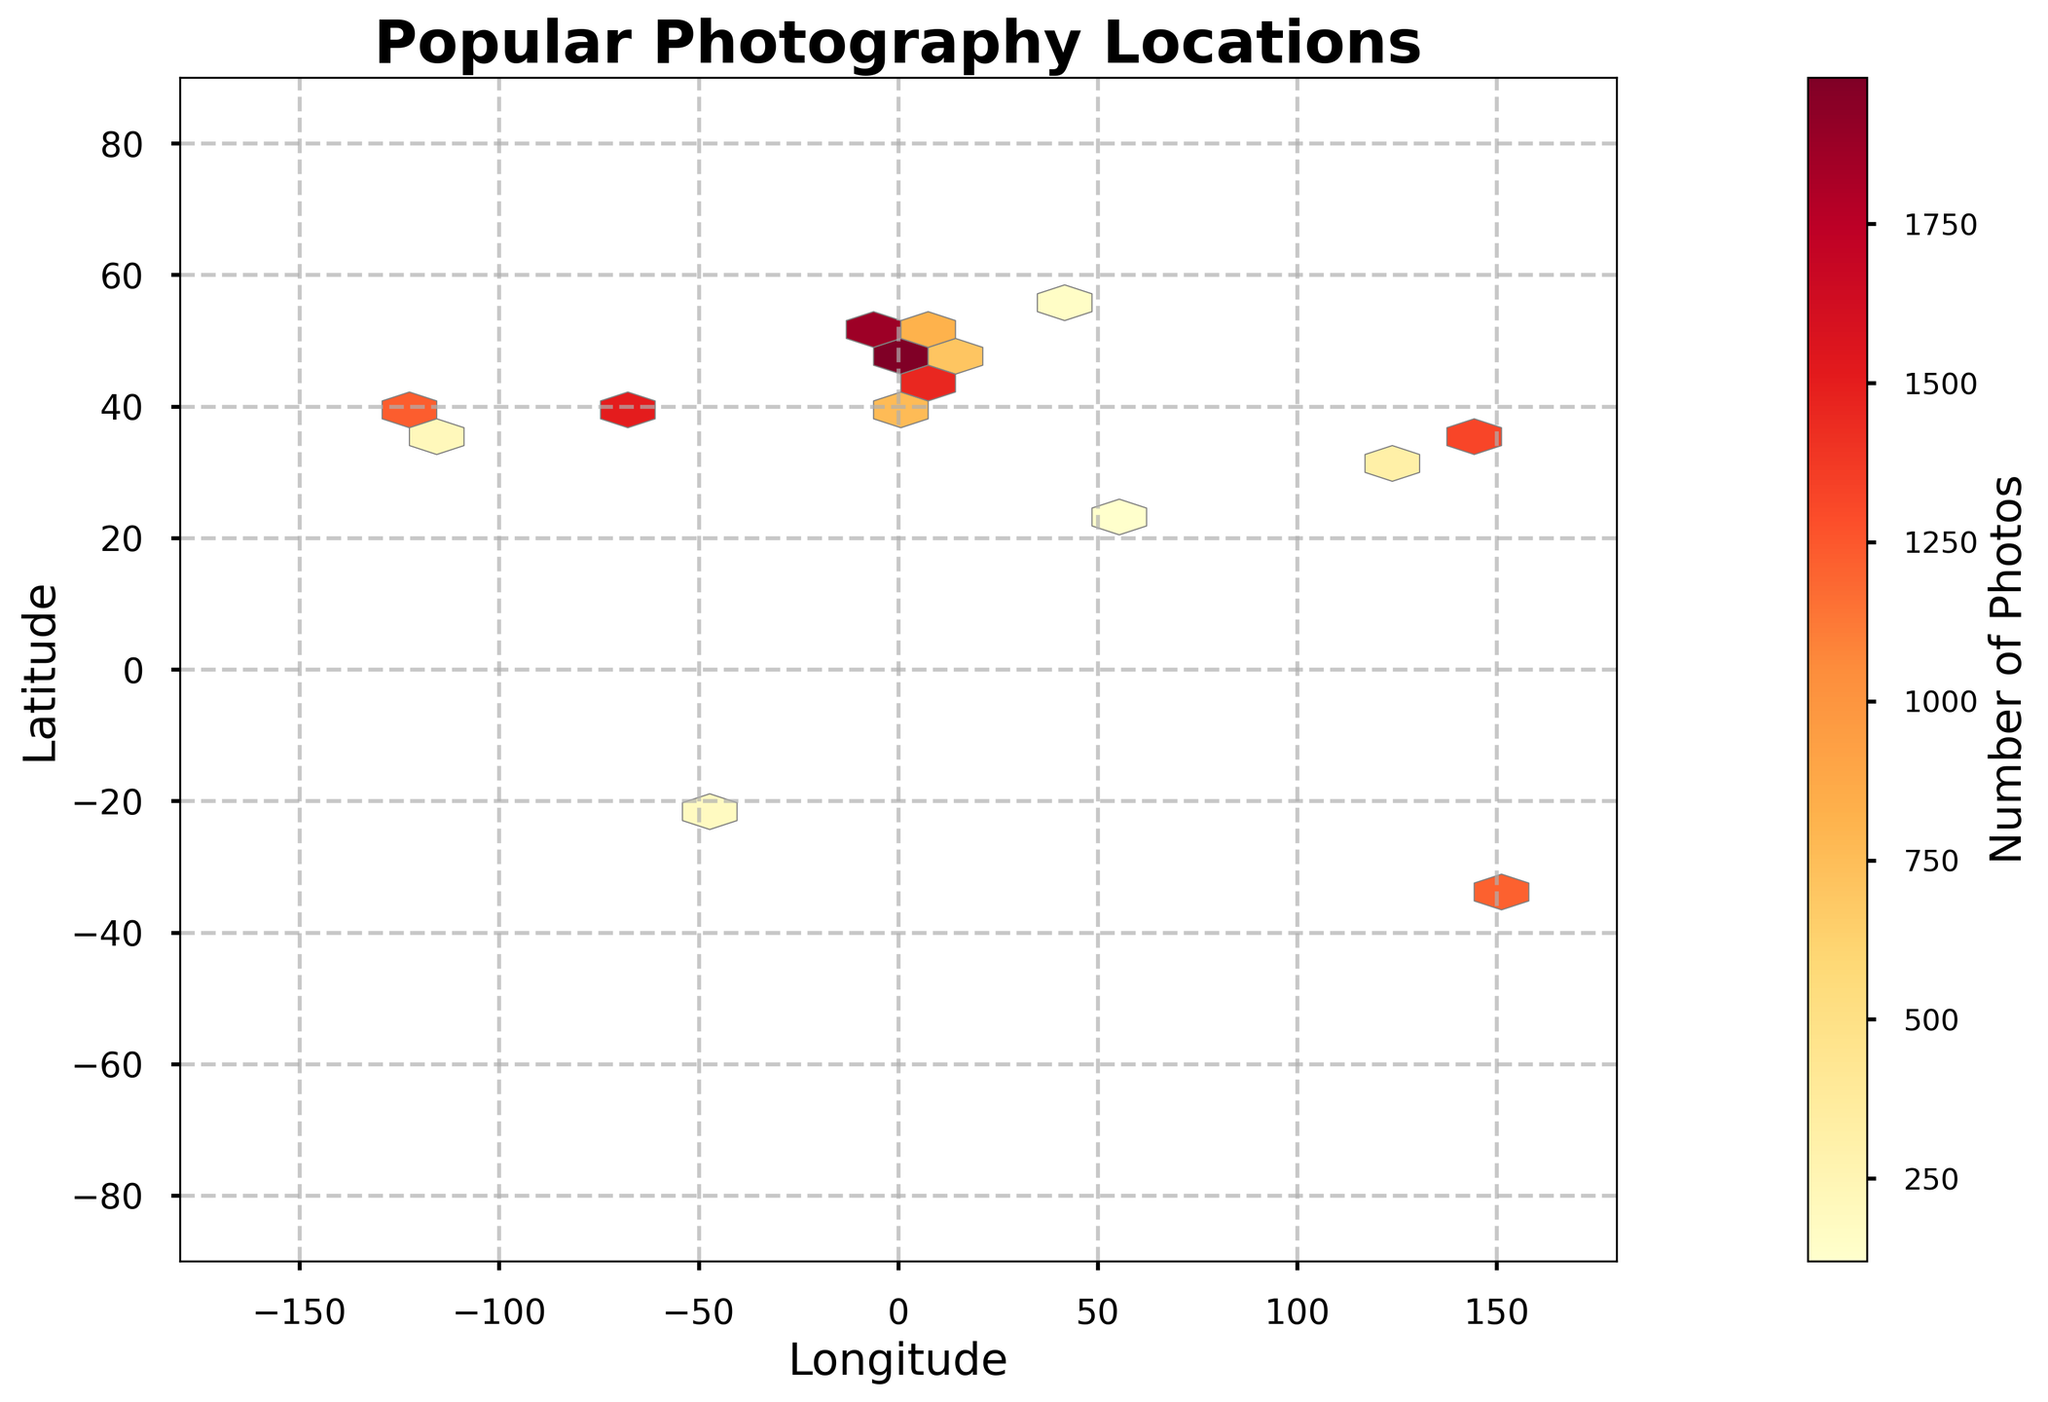What's the title of the figure? The title is displayed at the top center of the plot. It provides a direct description of what the figure represents.
Answer: Popular Photography Locations What does the color bar represent? The color bar gives information about the numerical range of the data represented by colors in the hexbin. Darker colors indicate higher values and lighter colors indicate lower values of a specific measure, which in this case is the number of photos.
Answer: Number of Photos What are the labels of the x and y axes? The x-axis label is found below the horizontal axis and refers to "Longitude", while the y-axis label is found to the left of the vertical axis and refers to "Latitude". These labels indicate the geographical coordinates used in the plot.
Answer: Longitude and Latitude Which location has the highest number of photos? The hexbin plot uses color intensity to represent the number of photos; therefore, the darkest and most intense color will indicate the location with the highest photo count. Checking the data values, the location with latitude 40.689247 and longitude -74.044502 has the highest count.
Answer: Latitude 40.689247 and Longitude -74.044502 Between which two latitude lines do most popular photography locations fall? By observing the density of the hexbin and counting the concentration of hexagons as they move vertically, most popular photography locations seem to fall between the latitude lines of approximately 30 to 50 degrees.
Answer: 30 to 50 degrees How does the number of photos change as you move from longitude -50 to 50? By observing the hexbin plot horizontally from longitude -50 to 50, one must assess the change in color intensity. The concentration of darker hexagons decreases as you move towards the center, indicating a reduction in the number of photos.
Answer: The number of photos generally decreases What is the longitude and latitude of the location with the second-highest photo count? From the data values, the location with the second-highest photo count has latitude 48.858844 and longitude 2.294351. This can be cross-verified by checking the intense colors on the plot compared to the highest point.
Answer: Latitude 48.858844 and Longitude 2.294351 In which hemisphere (Northern or Southern) are most popular photography locations? By observing the distribution of hexagons across the latitude, most of the intense color hexagons (indicating higher photo counts) appear in the Northern hemisphere.
Answer: Northern Hemisphere Are there any popular photography locations near the equator? To determine this, one must look around the equator line (latitude 0 degrees) to see any clusters of hexagons with considerable color intensity. Since there are minimal or no intense colors near the center, this indicates few to none popular locations near the equator.
Answer: No Is there any clustering of popular photography locations on the west and east coasts of the United States? By looking at areas around the longitudes corresponding to the West (-122) and East (-73) coasts of the US and checking for dense color patches, one can observe noticeable clustering in these regions. This indicates popular photography locations.
Answer: Yes 